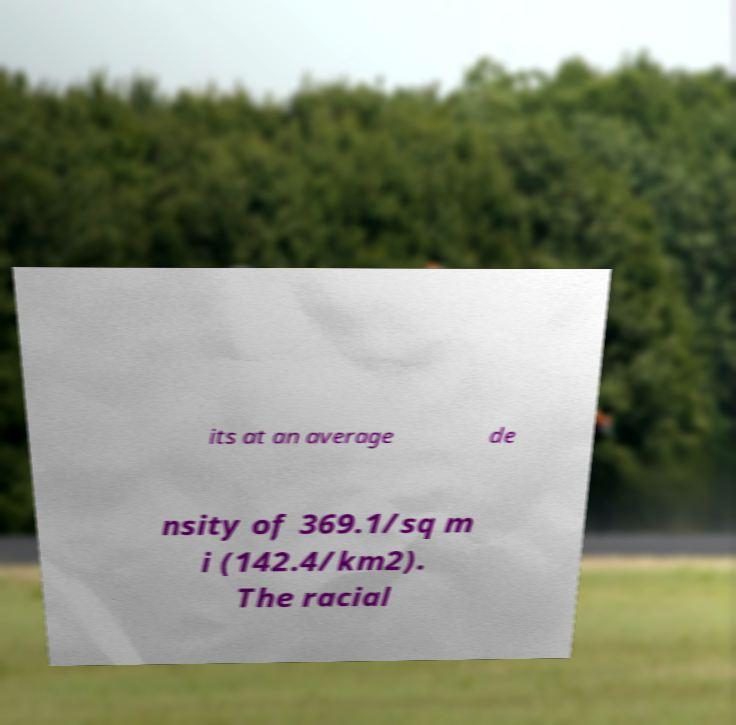There's text embedded in this image that I need extracted. Can you transcribe it verbatim? its at an average de nsity of 369.1/sq m i (142.4/km2). The racial 